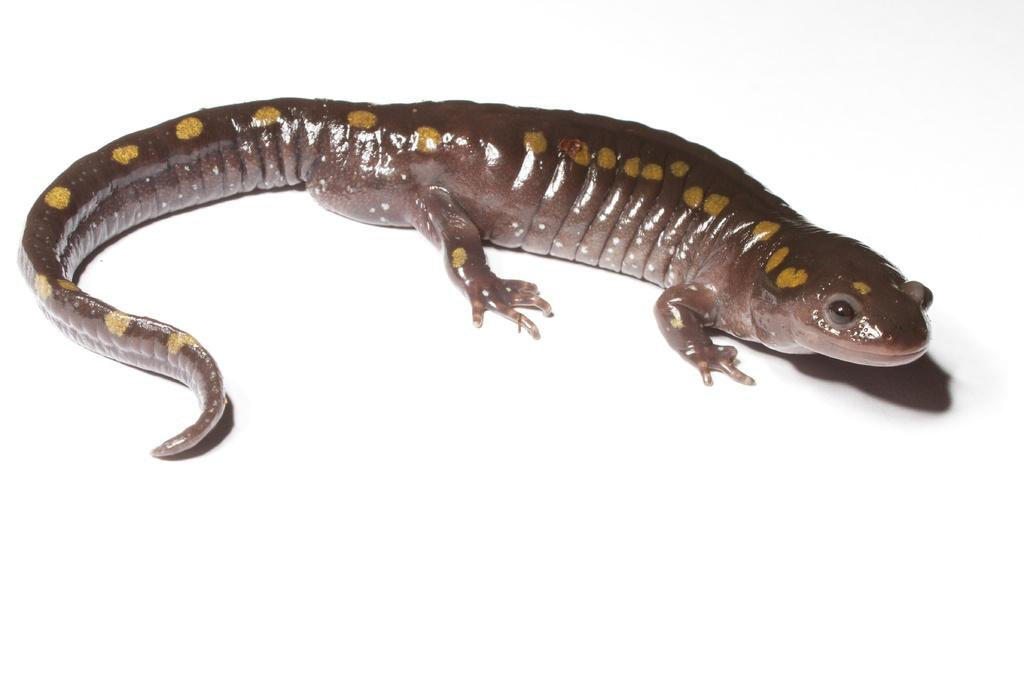What type of animal is in the image? There is a salamander in the image. What is the color of the surface the salamander is on? The salamander is on a white surface. What type of advice can be seen written on the quince in the image? There is no quince or advice present in the image; it features a salamander on a white surface. 